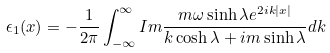<formula> <loc_0><loc_0><loc_500><loc_500>\epsilon _ { 1 } ( x ) = - \frac { 1 } { 2 \pi } \int _ { - \infty } ^ { \infty } I m \frac { m \omega \sinh \lambda e ^ { 2 i k | x | } } { k \cosh \lambda + i m \sinh \lambda } d k</formula> 